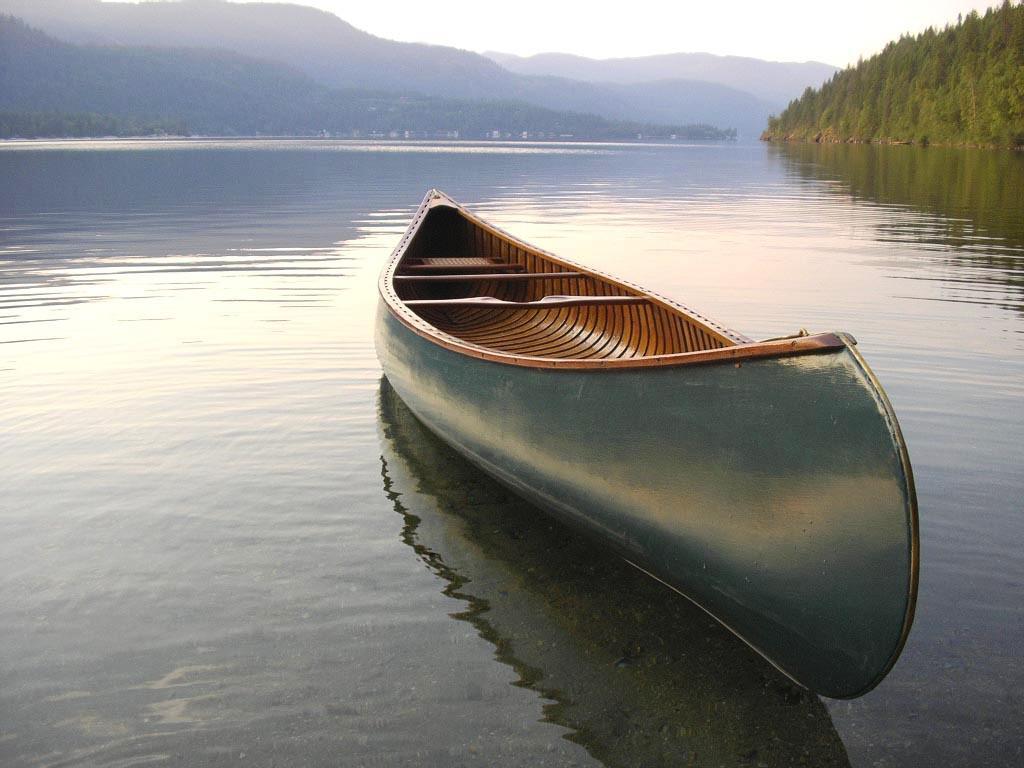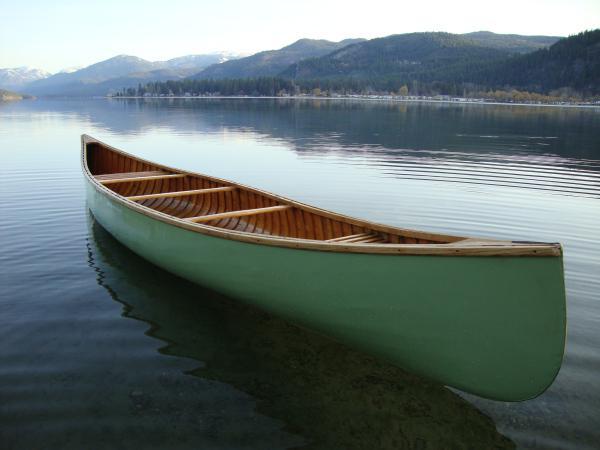The first image is the image on the left, the second image is the image on the right. Analyze the images presented: Is the assertion "Both images contain a canoe that is turned toward the right side of the photo." valid? Answer yes or no. Yes. 